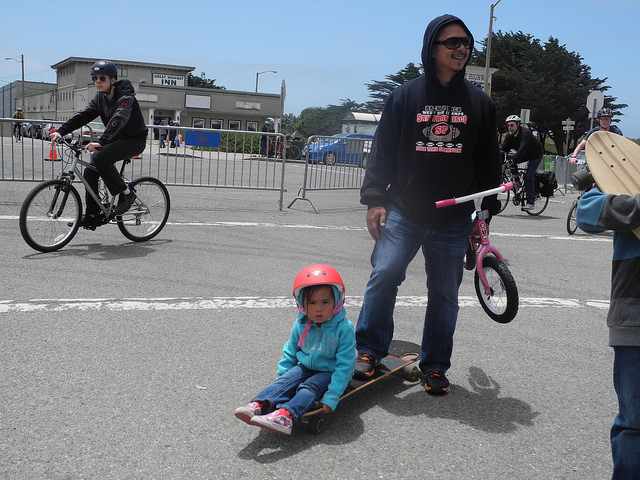Identify the text displayed in this image. SF 